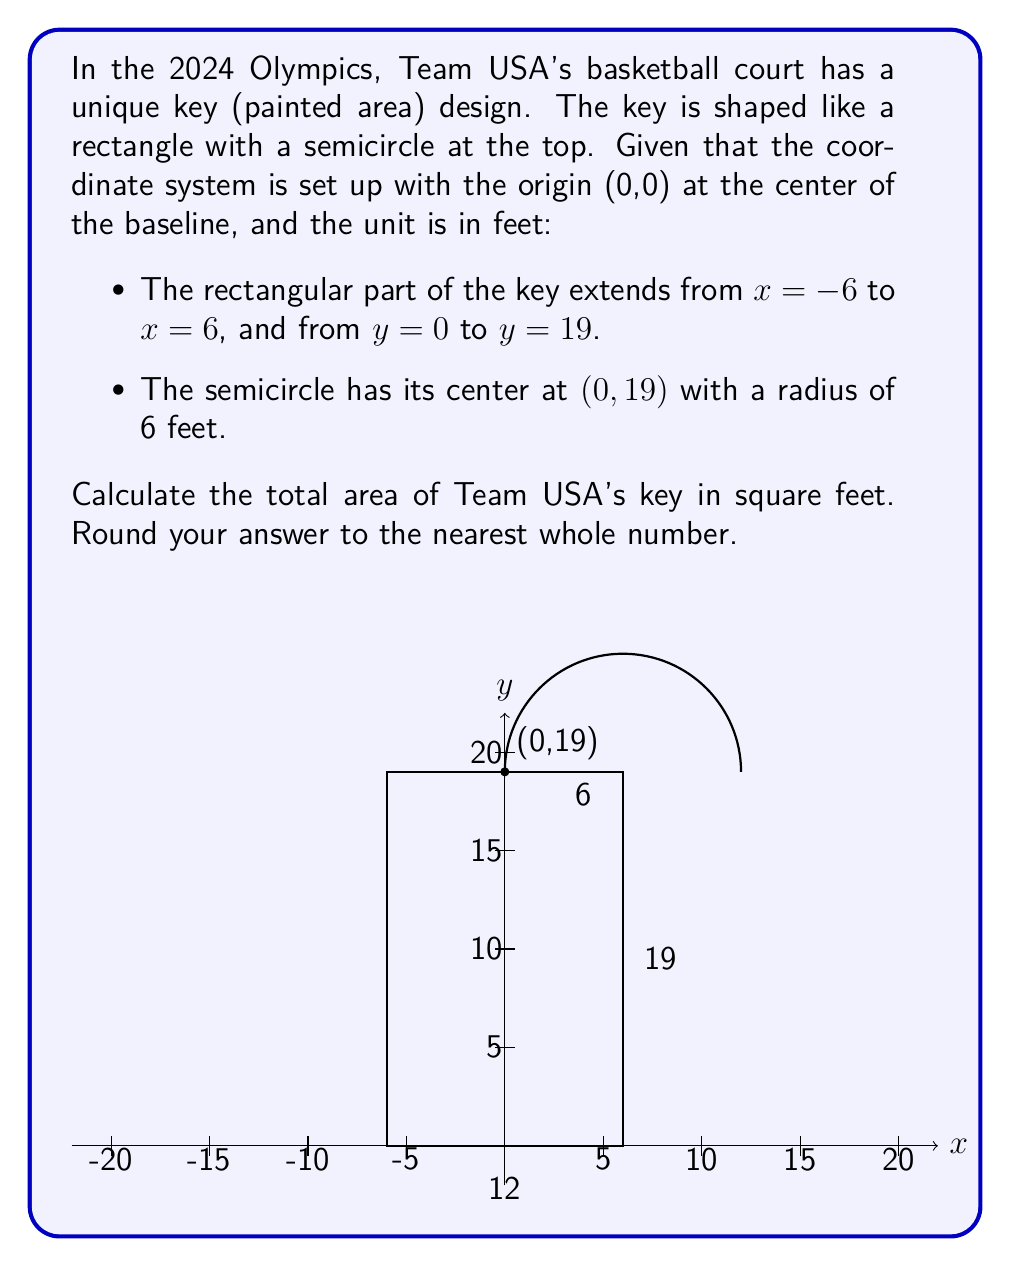Teach me how to tackle this problem. Let's break this problem down into two parts: the area of the rectangle and the area of the semicircle.

1) Area of the rectangle:
   The width of the rectangle is 12 feet (from x = -6 to x = 6).
   The height of the rectangle is 19 feet (from y = 0 to y = 19).
   
   Area of rectangle = width × height
   $$A_r = 12 \times 19 = 228$$ sq ft

2) Area of the semicircle:
   The radius of the semicircle is 6 feet.
   The area of a full circle is $\pi r^2$, so the area of a semicircle is half of that.
   
   Area of semicircle = $\frac{1}{2} \pi r^2$
   $$A_s = \frac{1}{2} \times \pi \times 6^2 = 18\pi$$ sq ft

3) Total area:
   The total area is the sum of the rectangle and semicircle areas.
   
   $$A_{total} = A_r + A_s = 228 + 18\pi$$

4) Calculating the result:
   $$A_{total} = 228 + 18\pi \approx 228 + 56.55 = 284.55$$ sq ft

5) Rounding to the nearest whole number:
   285 sq ft

Therefore, the total area of Team USA's key is approximately 285 square feet.
Answer: 285 sq ft 